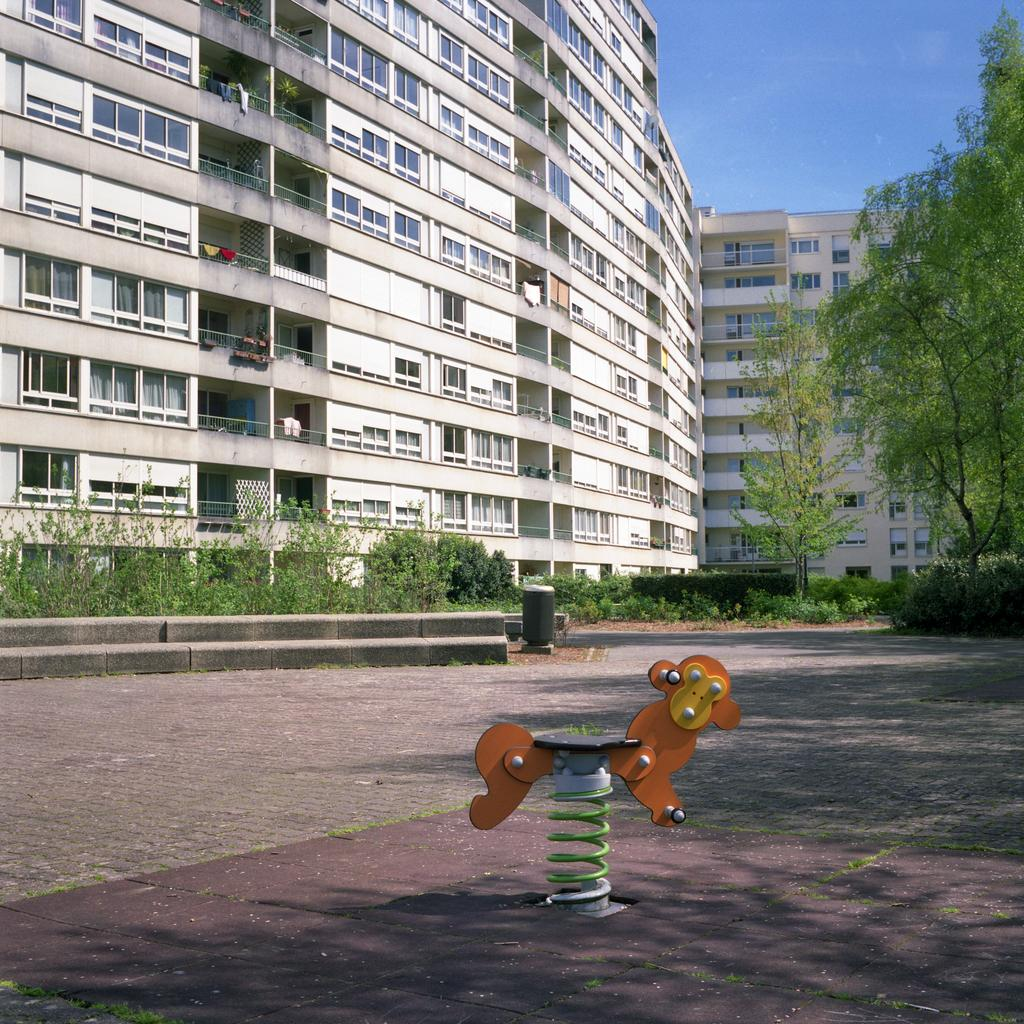What type of structures are visible in the image? There are buildings with windows in the image. What can be seen hanging in the image? Clothes are hanging in the image. What type of vegetation is present in the image? There are trees and plants in the image. What object is used for waste disposal in the image? There is a dustbin in the image. What type of playground equipment is visible in the image? There is a seesaw in the image. What type of hole can be seen in the image? There is no hole present in the image. What effect does the curve have on the buildings in the image? There is no curve mentioned in the image, so it's not possible to determine any effect on the buildings. 